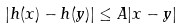Convert formula to latex. <formula><loc_0><loc_0><loc_500><loc_500>| h ( x ) - h ( y ) | \leq A | x - y |</formula> 